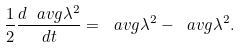Convert formula to latex. <formula><loc_0><loc_0><loc_500><loc_500>\frac { 1 } { 2 } \frac { d \ a v g { \lambda } ^ { 2 } } { d t } = \ a v g { \lambda ^ { 2 } } - \ a v g { \lambda } ^ { 2 } .</formula> 